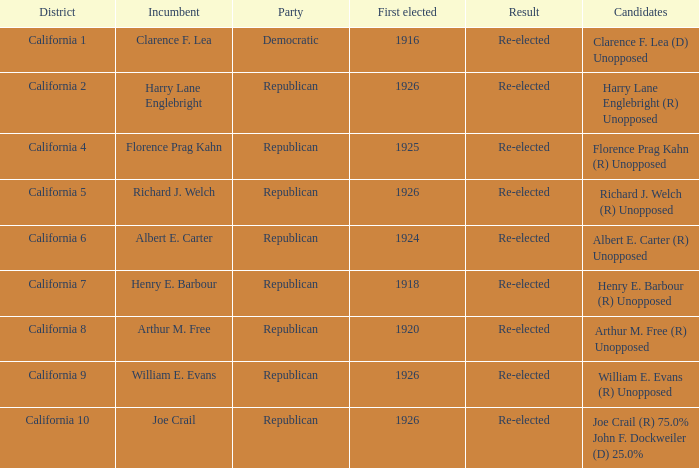What's the district with candidates being harry lane englebright (r) unopposed California 2. 